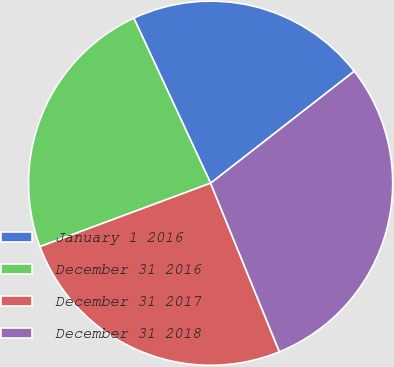<chart> <loc_0><loc_0><loc_500><loc_500><pie_chart><fcel>January 1 2016<fcel>December 31 2016<fcel>December 31 2017<fcel>December 31 2018<nl><fcel>21.4%<fcel>23.73%<fcel>25.5%<fcel>29.37%<nl></chart> 